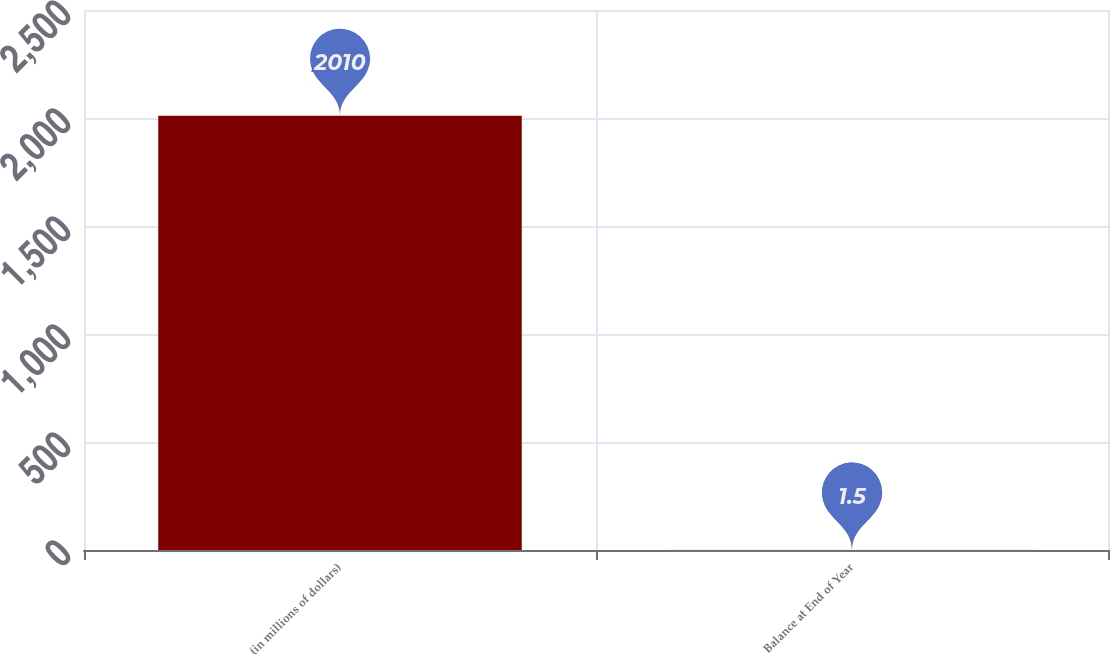<chart> <loc_0><loc_0><loc_500><loc_500><bar_chart><fcel>(in millions of dollars)<fcel>Balance at End of Year<nl><fcel>2010<fcel>1.5<nl></chart> 